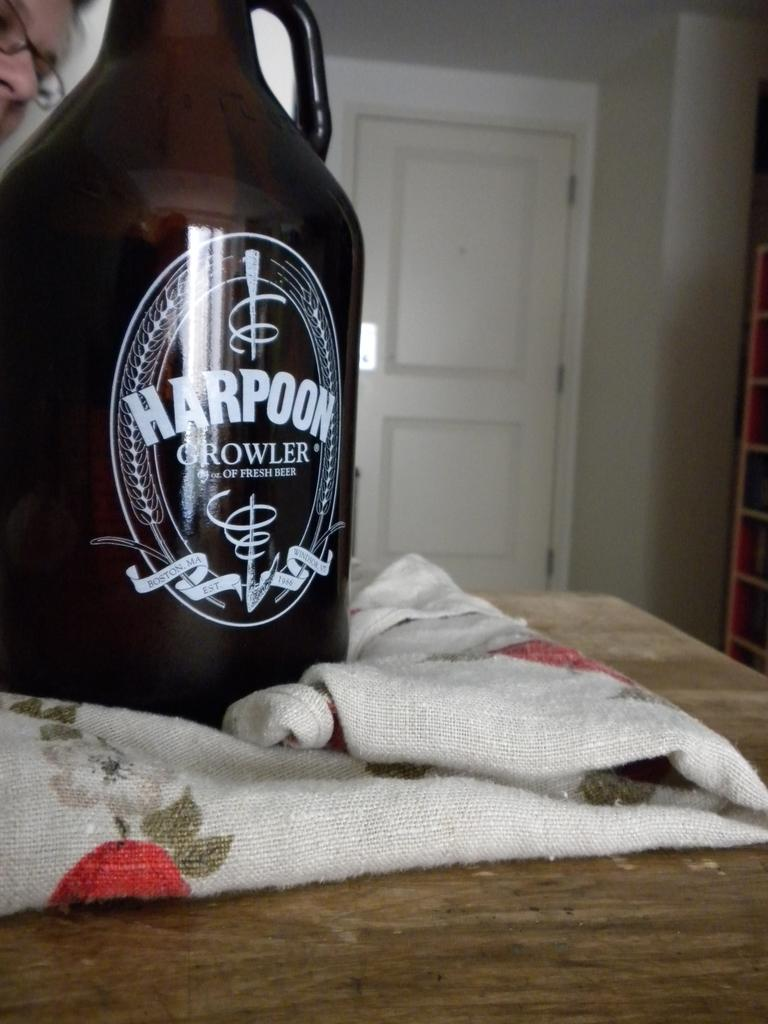<image>
Render a clear and concise summary of the photo. A kitchen counter that has a dish cloth on it with a dark brown bottle on top of it that reads Harpoon Crowler 